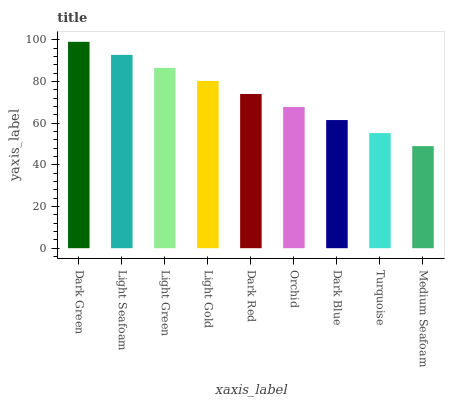Is Medium Seafoam the minimum?
Answer yes or no. Yes. Is Dark Green the maximum?
Answer yes or no. Yes. Is Light Seafoam the minimum?
Answer yes or no. No. Is Light Seafoam the maximum?
Answer yes or no. No. Is Dark Green greater than Light Seafoam?
Answer yes or no. Yes. Is Light Seafoam less than Dark Green?
Answer yes or no. Yes. Is Light Seafoam greater than Dark Green?
Answer yes or no. No. Is Dark Green less than Light Seafoam?
Answer yes or no. No. Is Dark Red the high median?
Answer yes or no. Yes. Is Dark Red the low median?
Answer yes or no. Yes. Is Medium Seafoam the high median?
Answer yes or no. No. Is Dark Blue the low median?
Answer yes or no. No. 